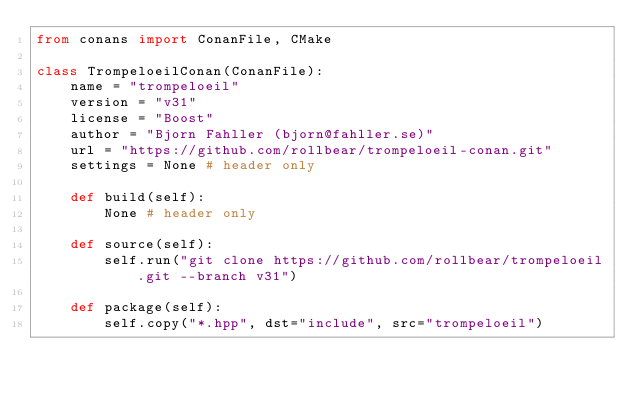Convert code to text. <code><loc_0><loc_0><loc_500><loc_500><_Python_>from conans import ConanFile, CMake

class TrompeloeilConan(ConanFile):
    name = "trompeloeil"
    version = "v31"
    license = "Boost"
    author = "Bjorn Fahller (bjorn@fahller.se)"
    url = "https://github.com/rollbear/trompeloeil-conan.git"
    settings = None # header only

    def build(self):
        None # header only

    def source(self):
        self.run("git clone https://github.com/rollbear/trompeloeil.git --branch v31")

    def package(self):
        self.copy("*.hpp", dst="include", src="trompeloeil")
</code> 